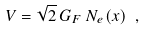<formula> <loc_0><loc_0><loc_500><loc_500>V = \sqrt { 2 } \, G _ { F } \, N _ { e } ( x ) \ ,</formula> 